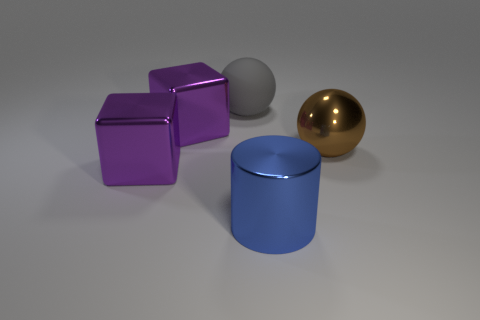How many purple blocks must be subtracted to get 1 purple blocks? 1 Add 1 blue cylinders. How many objects exist? 6 Subtract all balls. How many objects are left? 3 Subtract all large gray things. Subtract all objects. How many objects are left? 3 Add 2 big cubes. How many big cubes are left? 4 Add 4 green spheres. How many green spheres exist? 4 Subtract 1 gray spheres. How many objects are left? 4 